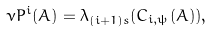Convert formula to latex. <formula><loc_0><loc_0><loc_500><loc_500>\nu P ^ { i } ( A ) = \lambda _ { ( i + 1 ) s } ( C _ { i , \psi } ( A ) ) ,</formula> 